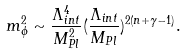<formula> <loc_0><loc_0><loc_500><loc_500>m ^ { 2 } _ { \phi } \sim \frac { \Lambda _ { i n t } ^ { 4 } } { M _ { P l } ^ { 2 } } ( \frac { \Lambda _ { i n t } } { M _ { P l } } ) ^ { 2 ( n + \gamma - 1 ) } .</formula> 